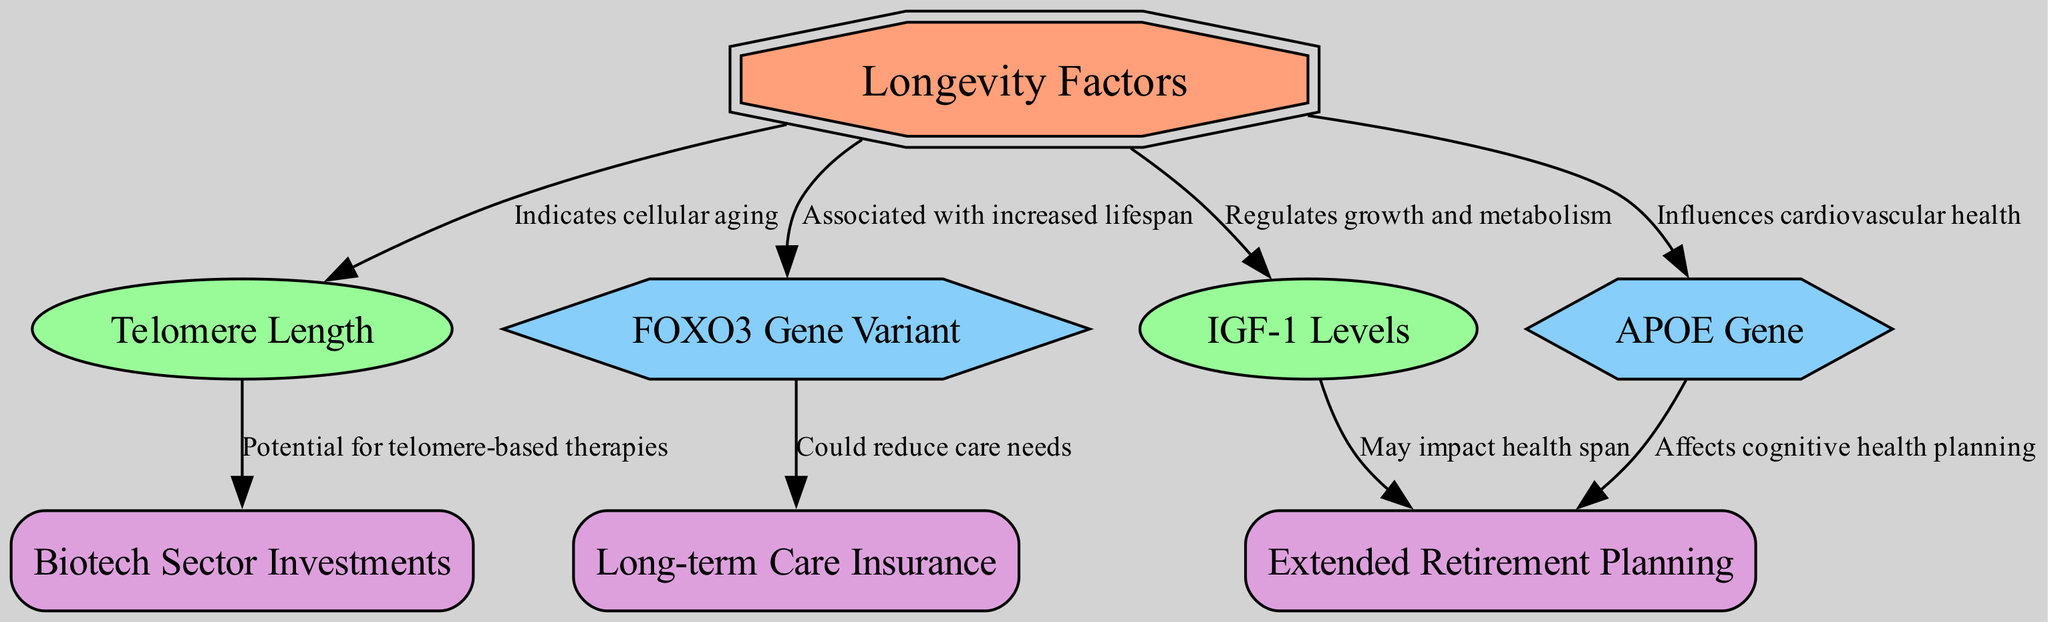What is the central node of the diagram? The central node of the diagram is labeled "Longevity Factors," which is identified as the main focus of the diagram.
Answer: Longevity Factors How many biological markers are represented in the diagram? There are two biological markers in the diagram: "Telomere Length" and "IGF-1 Levels." Counting these markers gives a total of two.
Answer: 2 What is the relationship between "Telomere Length" and "Biotech Sector Investments"? The edge connecting "Telomere Length" to "Biotech Sector Investments" is labeled "Potential for telomere-based therapies," indicating a causal relationship between telomere length and investment opportunities in biotechnology.
Answer: Potential for telomere-based therapies Which gene variant is associated with increased lifespan? The "FOXO3 Gene Variant" is explicitly described in the diagram as being associated with increased lifespan, making it the relevant answer to the question.
Answer: FOXO3 Gene Variant What impact do "IGF-1 Levels" have on "Retirement"? The edge connecting "IGF-1 Levels" to "Retirement" indicates that "IGF-1 Levels" may impact health span, which is important for planning for retirement and health expenses.
Answer: May impact health span How does the "APOE Gene" influence retirement planning? The edge connecting "APOE Gene" and "Retirement" indicates that the "APOE Gene" affects cognitive health planning, which is crucial for making informed decisions about retirement.
Answer: Affects cognitive health planning Which factor is likely to reduce long-term care needs? The "FOXO3 Gene Variant" is connected to "Long-term Care Insurance," with the edge indicating it could reduce care needs, making it the relevant factor here.
Answer: FOXO3 Gene Variant What is the link between "Telomere Length" and longevity? The link is described by the edge that states "Indicates cellular aging," suggesting that telomere length is a significant factor affecting overall longevity through cellular health.
Answer: Indicates cellular aging Which investment strategy is associated with biological markers? "Biotech Sector Investments" is the strategy associated with the biological markers, specifically linked through "Telomere Length," which denotes the potential for therapies leveraging this biological factor.
Answer: Biotech Sector Investments 